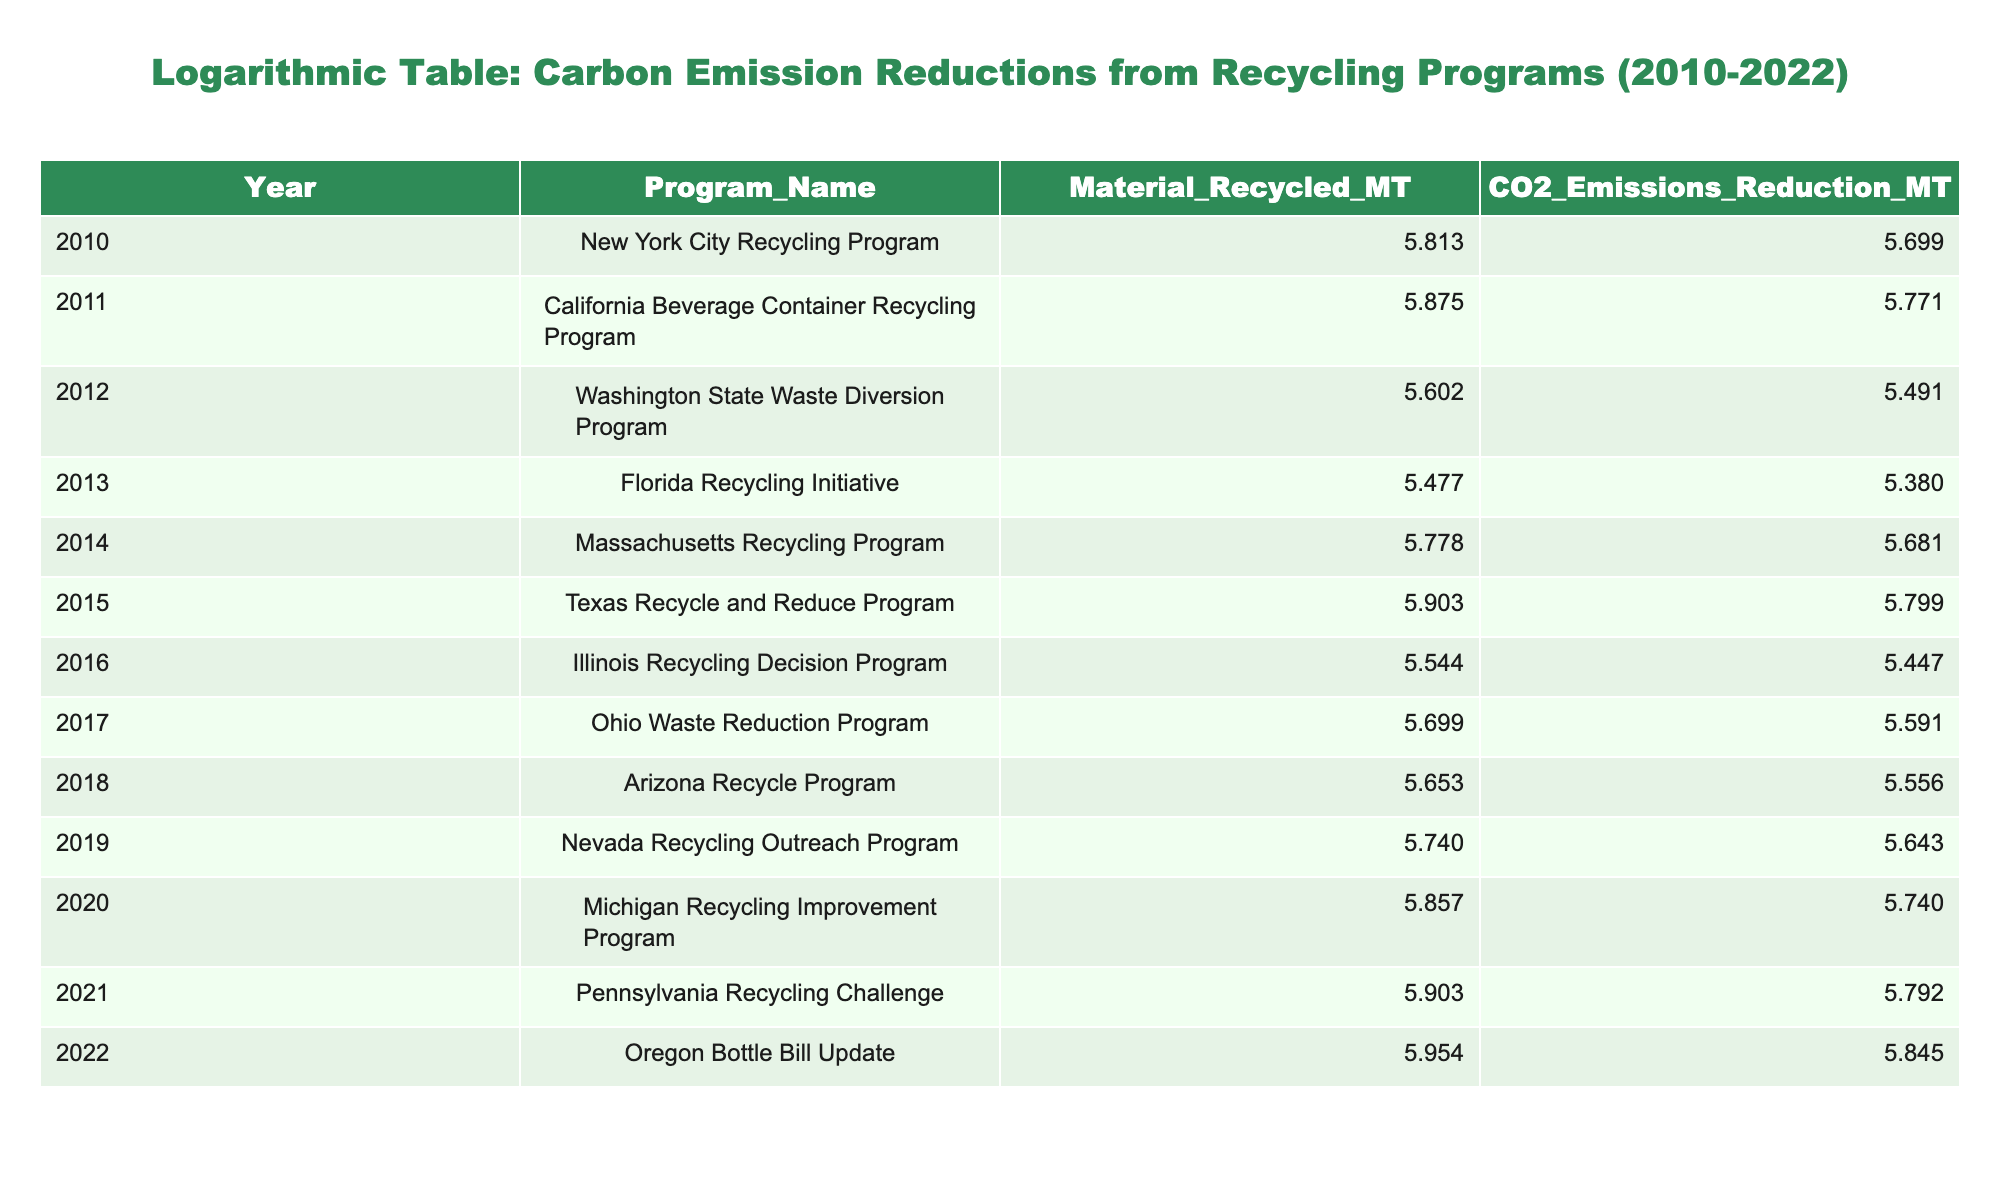What is the CO2 emissions reduction attributed to the Oregon Bottle Bill Update in 2022? The table shows a specific entry for the year 2022 under the Program_Name "Oregon Bottle Bill Update," which indicates a CO2 emissions reduction of 700000 metric tons.
Answer: 700000 Which program had the highest material recycled in metric tons? By scanning the table, the program with the highest value under the column "Material_Recycled_MT" is the "Oregon Bottle Bill Update" in 2022, which recorded 900000 metric tons.
Answer: Oregon Bottle Bill Update What was the average CO2 emissions reduction from 2010 to 2022? To find the average, first sum all the CO2 emissions reduction values: 500000 + 590000 + 310000 + 240000 + 480000 + 630000 + 280000 + 390000 + 360000 + 550000 + 620000 + 700000 = 4550000. There are 13 programs (one for each year), so the average is 4550000 / 13 ≈ 350000.
Answer: 350000 Is it true that the California Beverage Container Recycling Program reduced more CO2 emissions than the Florida Recycling Initiative? By comparing the values in the table, the California Beverage Container Recycling Program indicates a CO2 emissions reduction of 590000 metric tons, while the Florida Recycling Initiative shows a reduction of 240000 metric tons. Since 590000 is greater than 240000, the statement is true.
Answer: Yes Which year had the largest increase in CO2 emissions reduction compared to the previous year? To find the largest increase, calculate the difference between each consecutive year's CO2 emissions reduction: 590000 - 500000 = 90000, 310000 - 590000 = -280000, 240000 - 310000 = -70000, etc. The largest increase is from 2020 (550000) to 2021 (620000), which is an increase of 70000 metric tons.
Answer: 70000 How many programs had a CO2 emissions reduction of more than 500000 metric tons? By reviewing the CO2 emissions reduction column, the programs with reductions greater than 500000 metric tons are: New York City (500000), California (590000), Texas (630000), Pennsylvania (620000), and Oregon (700000). There are 5 programs in total.
Answer: 5 What is the difference in CO2 emissions reduction between the Massachusetts Recycling Program and the Arizona Recycle Program? The CO2 emissions reduction for the Massachusetts Recycling Program is 480000 metric tons, and for the Arizona Recycle Program, it is 360000 metric tons. The difference is 480000 - 360000 = 120000 metric tons.
Answer: 120000 Which two programs combined result in the highest material recycled total? After reviewing the material recycled amounts, the Oregon Bottle Bill Update (900000) and the Texas Recycle and Reduce Program (800000) have the highest values. When combined: 900000 + 800000 = 1700000 metric tons.
Answer: 1700000 In 2016, did the Illinois Recycling Decision Program show a CO2 emissions reduction below 300000 metric tons? According to the table, the Illinois Recycling Decision Program indicates a CO2 emissions reduction of 280000 metric tons, which is indeed below 300000 metric tons.
Answer: Yes 